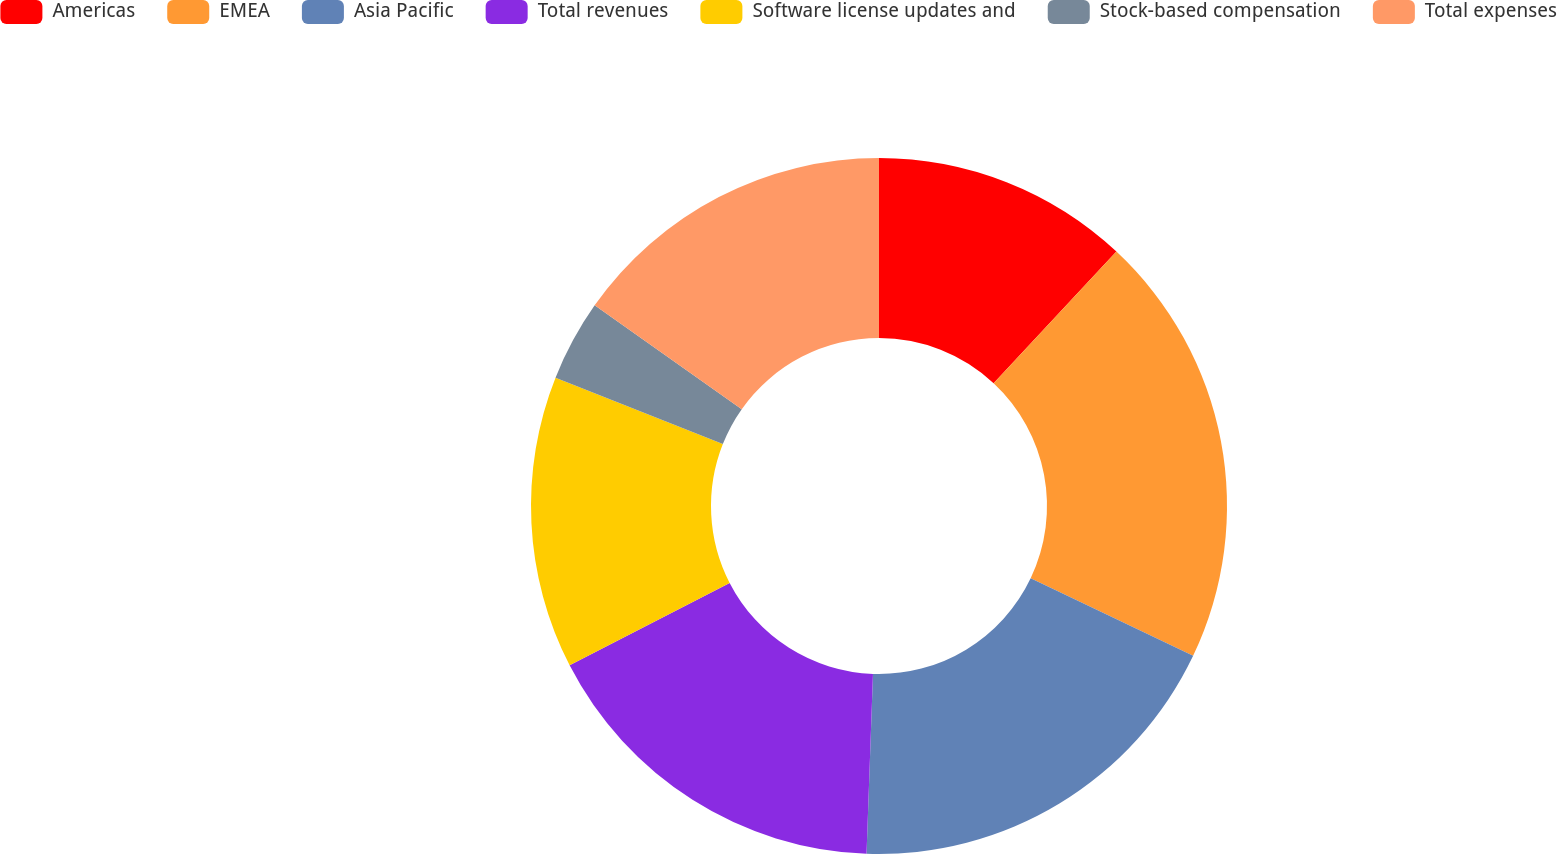<chart> <loc_0><loc_0><loc_500><loc_500><pie_chart><fcel>Americas<fcel>EMEA<fcel>Asia Pacific<fcel>Total revenues<fcel>Software license updates and<fcel>Stock-based compensation<fcel>Total expenses<nl><fcel>11.95%<fcel>20.13%<fcel>18.49%<fcel>16.86%<fcel>13.58%<fcel>3.77%<fcel>15.22%<nl></chart> 